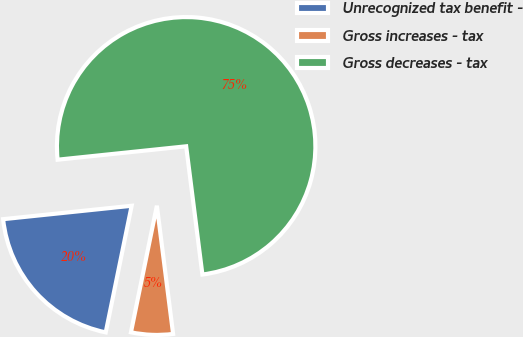Convert chart to OTSL. <chart><loc_0><loc_0><loc_500><loc_500><pie_chart><fcel>Unrecognized tax benefit -<fcel>Gross increases - tax<fcel>Gross decreases - tax<nl><fcel>20.13%<fcel>5.22%<fcel>74.65%<nl></chart> 